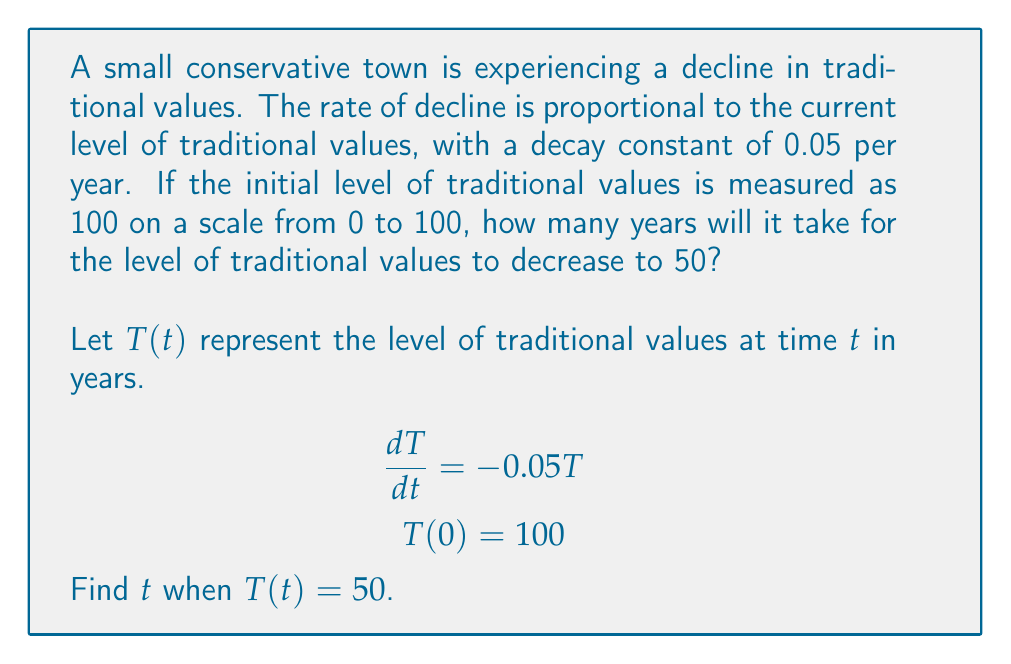Solve this math problem. To solve this first-order differential equation:

1) The general solution for this type of equation is:
   $$T(t) = Ce^{-0.05t}$$
   where $C$ is a constant.

2) Use the initial condition $T(0) = 100$ to find $C$:
   $$100 = Ce^{-0.05(0)} = C$$
   So, $C = 100$

3) The specific solution is:
   $$T(t) = 100e^{-0.05t}$$

4) To find when $T(t) = 50$, set up the equation:
   $$50 = 100e^{-0.05t}$$

5) Divide both sides by 100:
   $$0.5 = e^{-0.05t}$$

6) Take the natural logarithm of both sides:
   $$\ln(0.5) = -0.05t$$

7) Solve for $t$:
   $$t = \frac{\ln(0.5)}{-0.05} \approx 13.86$$

Therefore, it will take approximately 13.86 years for the level of traditional values to decrease to 50.
Answer: 13.86 years 